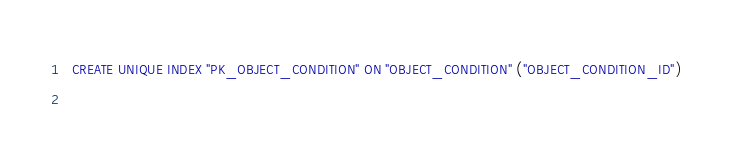<code> <loc_0><loc_0><loc_500><loc_500><_SQL_>
  CREATE UNIQUE INDEX "PK_OBJECT_CONDITION" ON "OBJECT_CONDITION" ("OBJECT_CONDITION_ID") 
  </code> 